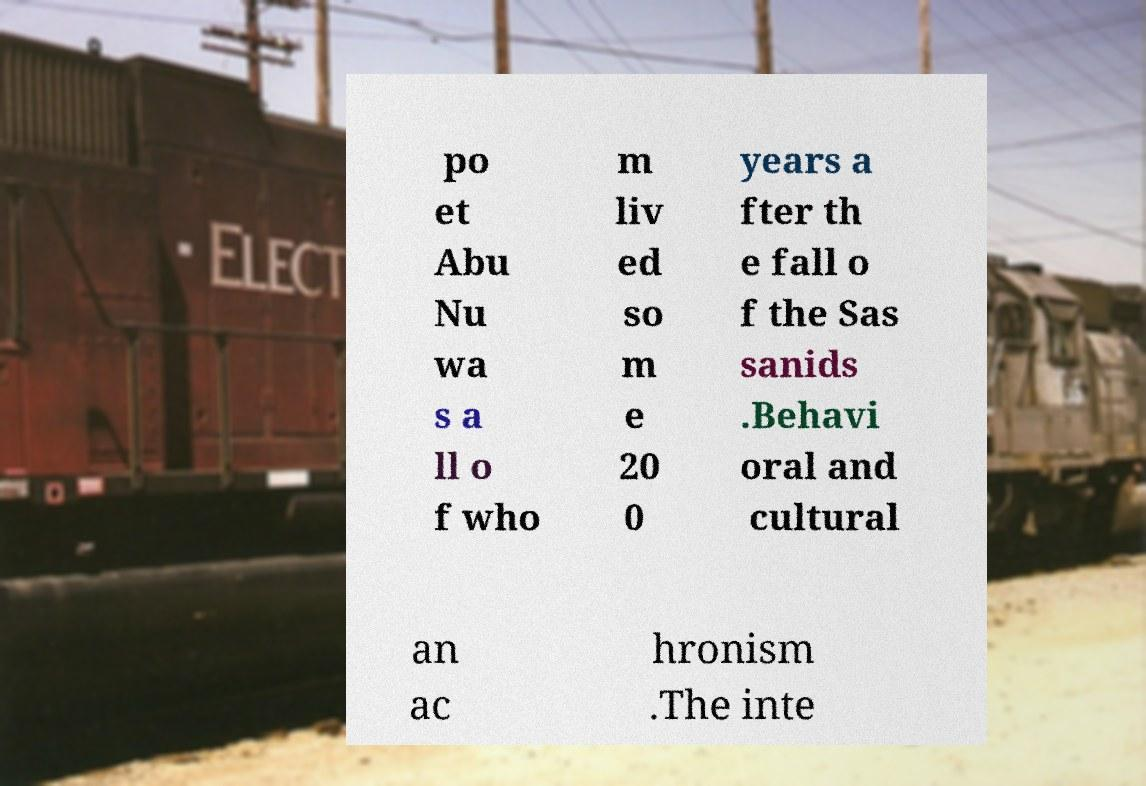Can you accurately transcribe the text from the provided image for me? po et Abu Nu wa s a ll o f who m liv ed so m e 20 0 years a fter th e fall o f the Sas sanids .Behavi oral and cultural an ac hronism .The inte 